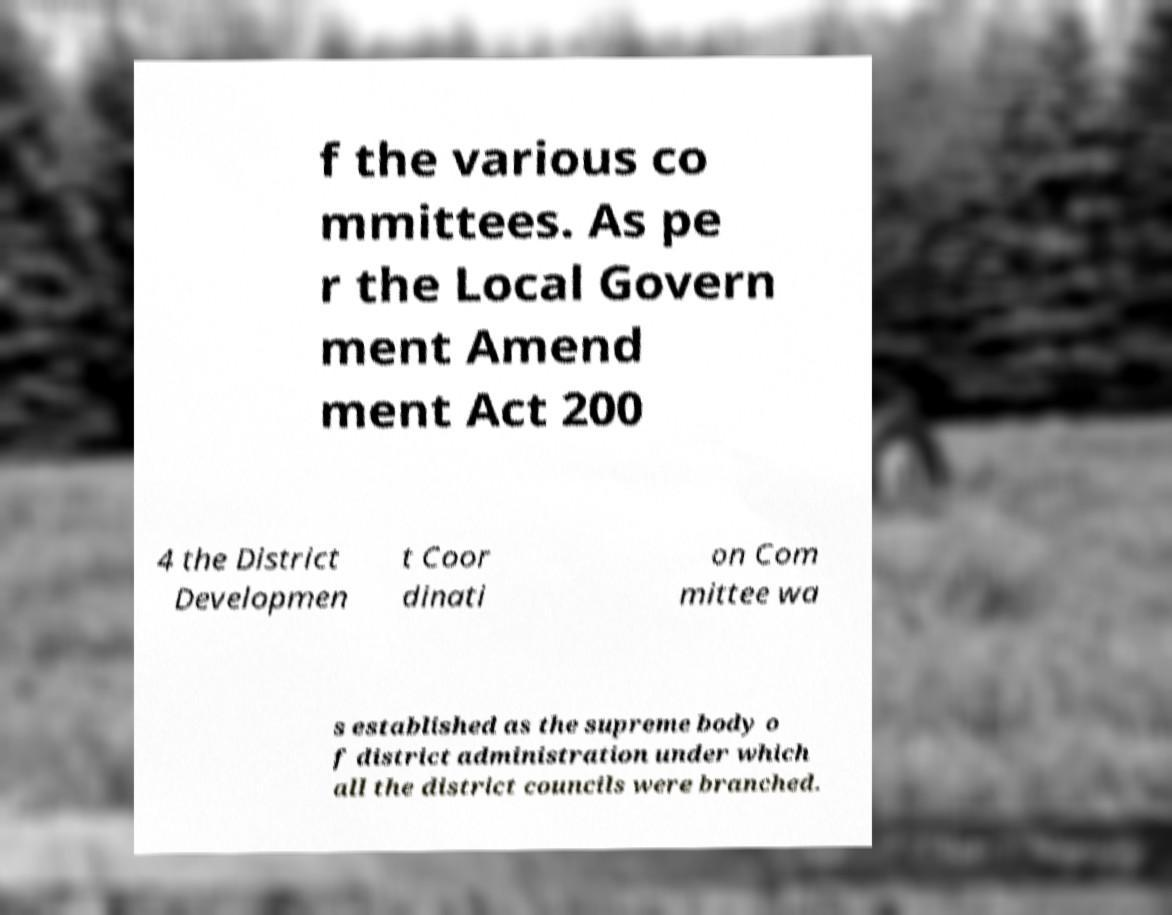What messages or text are displayed in this image? I need them in a readable, typed format. f the various co mmittees. As pe r the Local Govern ment Amend ment Act 200 4 the District Developmen t Coor dinati on Com mittee wa s established as the supreme body o f district administration under which all the district councils were branched. 